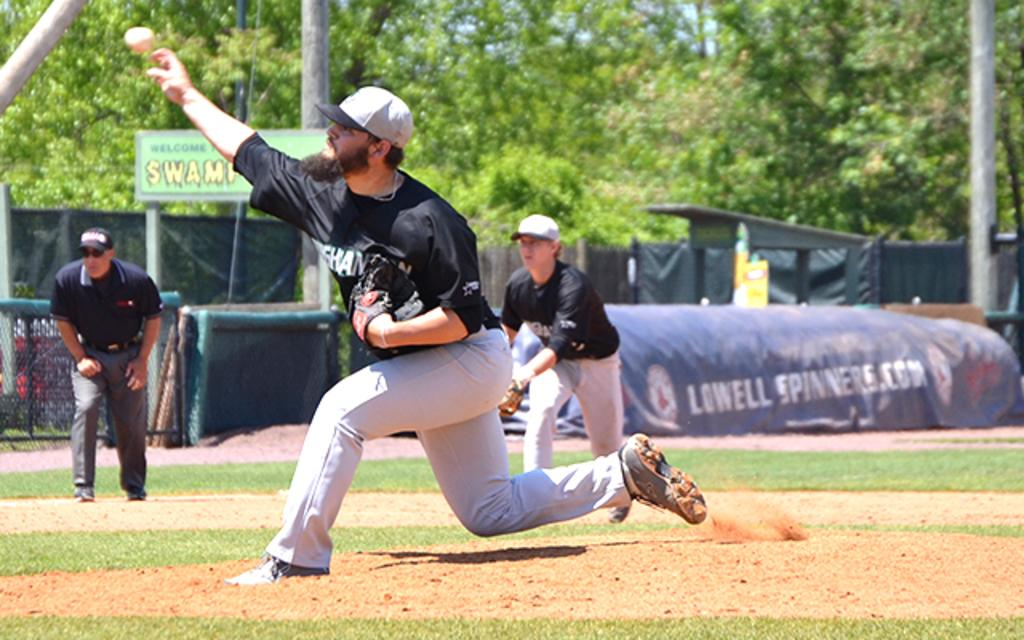<image>
Present a compact description of the photo's key features. An ad for Lowell Spinners can be seen near people playing baseball. 